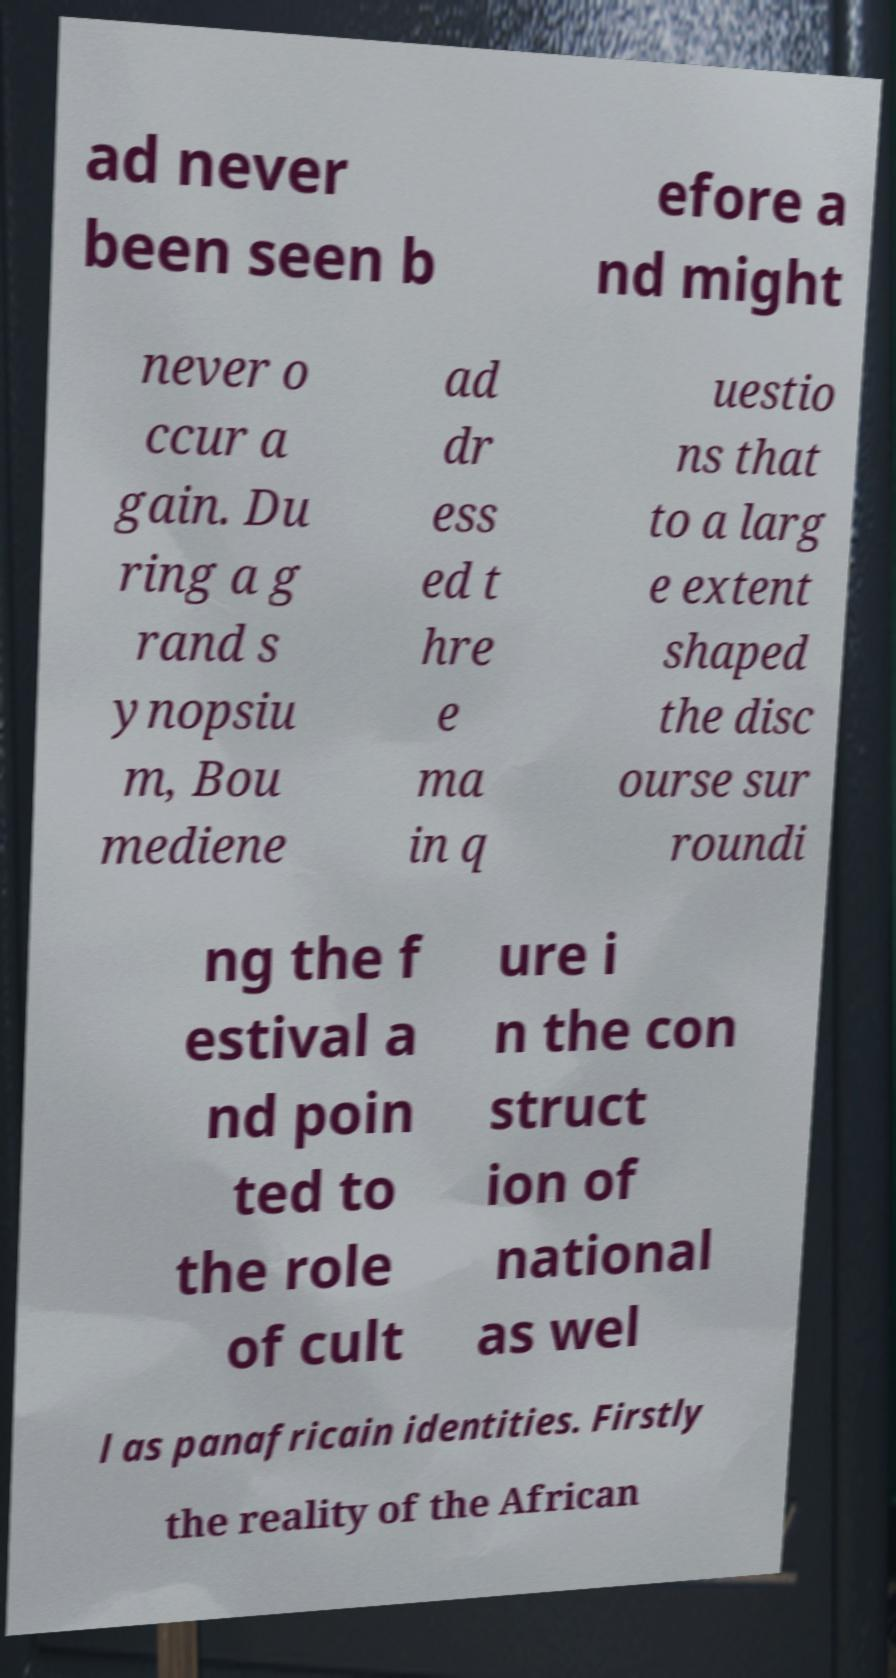For documentation purposes, I need the text within this image transcribed. Could you provide that? ad never been seen b efore a nd might never o ccur a gain. Du ring a g rand s ynopsiu m, Bou mediene ad dr ess ed t hre e ma in q uestio ns that to a larg e extent shaped the disc ourse sur roundi ng the f estival a nd poin ted to the role of cult ure i n the con struct ion of national as wel l as panafricain identities. Firstly the reality of the African 